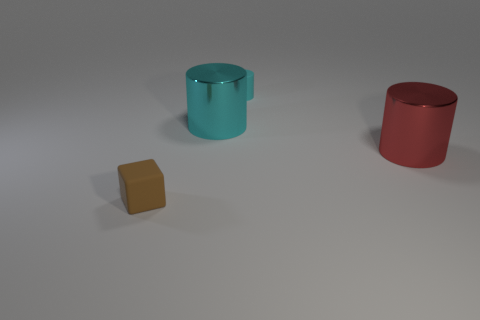Add 4 red things. How many objects exist? 8 Subtract all cylinders. How many objects are left? 1 Add 3 purple balls. How many purple balls exist? 3 Subtract 0 red cubes. How many objects are left? 4 Subtract all brown rubber blocks. Subtract all large objects. How many objects are left? 1 Add 1 cyan cylinders. How many cyan cylinders are left? 3 